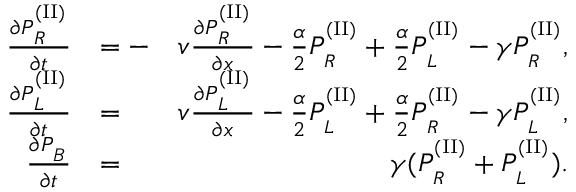Convert formula to latex. <formula><loc_0><loc_0><loc_500><loc_500>\begin{array} { r l r } { \frac { \partial P _ { _ { R } } ^ { ^ { ( I I ) } } } { \partial t } } & { = - } & { v \frac { \partial P _ { _ { R } } ^ { ^ { ( I I ) } } } { \partial x } - \frac { \alpha } { 2 } P _ { _ { R } } ^ { ^ { ( I I ) } } + \frac { \alpha } { 2 } P _ { _ { L } } ^ { ^ { ( I I ) } } - \gamma P _ { _ { R } } ^ { ^ { ( I I ) } } , } \\ { \frac { \partial P _ { _ { L } } ^ { ^ { ( I I ) } } } { \partial t } } & { = } & { v \frac { \partial P _ { _ { L } } ^ { ^ { ( I I ) } } } { \partial x } - \frac { \alpha } { 2 } P _ { _ { L } } ^ { ^ { ( I I ) } } + \frac { \alpha } { 2 } P _ { _ { R } } ^ { ^ { ( I I ) } } - \gamma P _ { _ { L } } ^ { ^ { ( I I ) } } , } \\ { \frac { \partial P _ { _ { B } } } { \partial t } } & { = } & { \gamma ( P _ { _ { R } } ^ { ^ { ( I I ) } } + P _ { _ { L } } ^ { ^ { ( I I ) } } ) . } \end{array}</formula> 